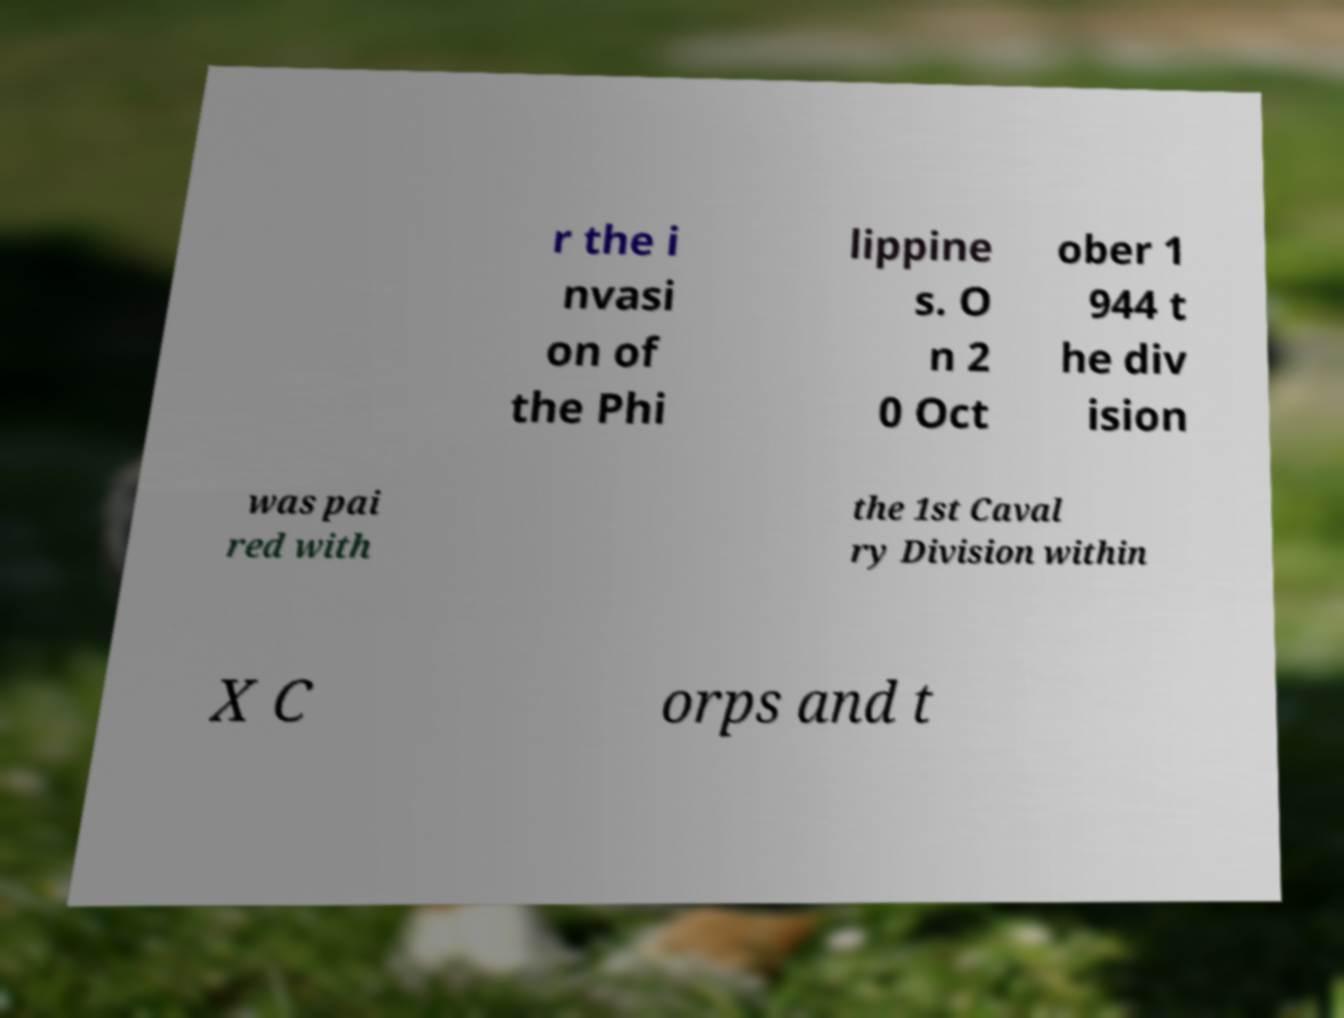Could you extract and type out the text from this image? r the i nvasi on of the Phi lippine s. O n 2 0 Oct ober 1 944 t he div ision was pai red with the 1st Caval ry Division within X C orps and t 